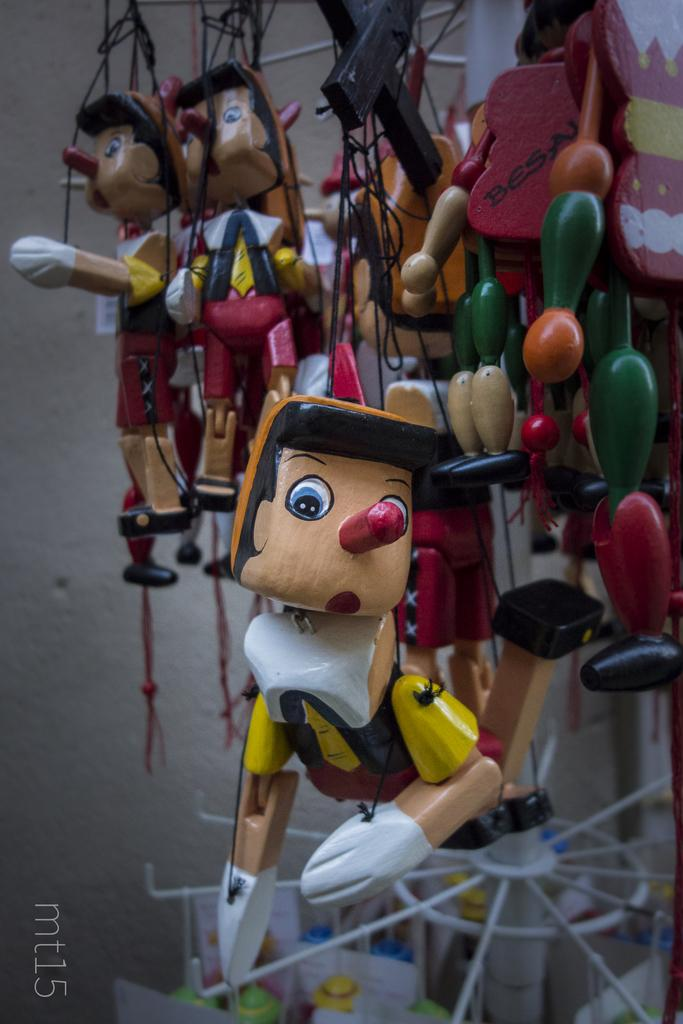What type of objects are in the image? There are puppets in the image. What are the ropes used for in the image? The ropes are black in color and are likely used to manipulate the puppets. Can you describe any additional features of the image? There is a watermark in the image. What can be seen in the background of the image? There are colorful things in the background of the image. What type of soup is being served in the image? There is no soup present in the image; it features puppets and black color ropes. What is the price of the quilt in the image? There is no quilt present in the image, so it is not possible to determine its price. 